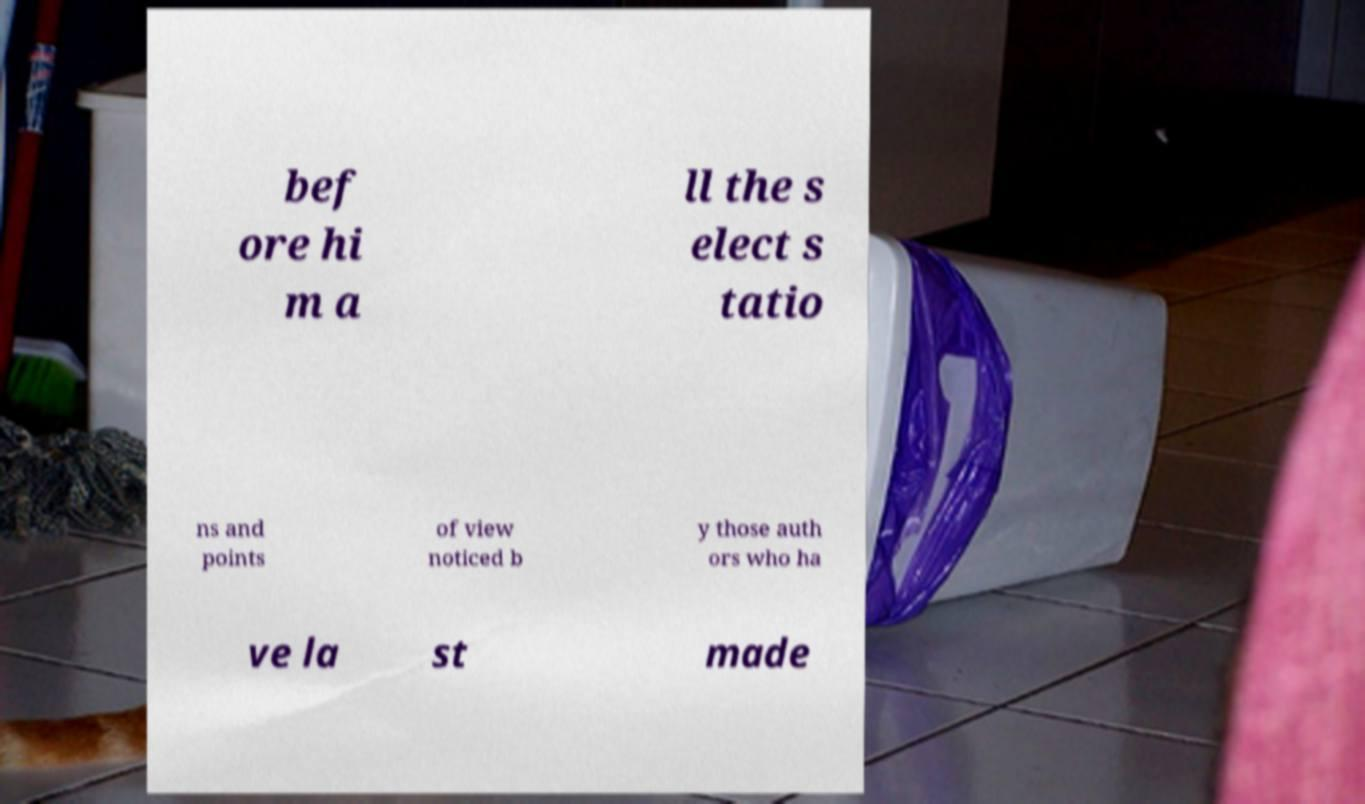Please identify and transcribe the text found in this image. bef ore hi m a ll the s elect s tatio ns and points of view noticed b y those auth ors who ha ve la st made 